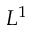<formula> <loc_0><loc_0><loc_500><loc_500>L ^ { 1 }</formula> 